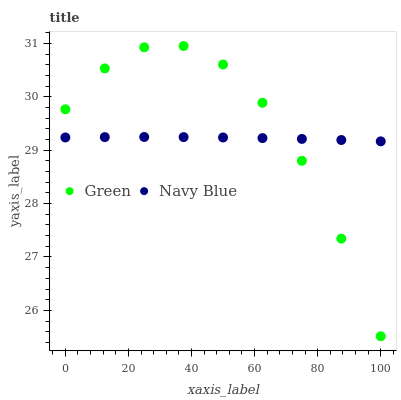Does Navy Blue have the minimum area under the curve?
Answer yes or no. Yes. Does Green have the maximum area under the curve?
Answer yes or no. Yes. Does Green have the minimum area under the curve?
Answer yes or no. No. Is Navy Blue the smoothest?
Answer yes or no. Yes. Is Green the roughest?
Answer yes or no. Yes. Is Green the smoothest?
Answer yes or no. No. Does Green have the lowest value?
Answer yes or no. Yes. Does Green have the highest value?
Answer yes or no. Yes. Does Green intersect Navy Blue?
Answer yes or no. Yes. Is Green less than Navy Blue?
Answer yes or no. No. Is Green greater than Navy Blue?
Answer yes or no. No. 